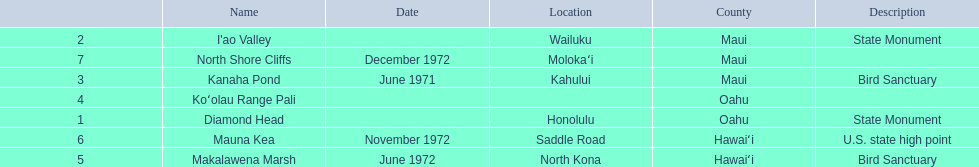What are all of the landmark names? Diamond Head, I'ao Valley, Kanaha Pond, Koʻolau Range Pali, Makalawena Marsh, Mauna Kea, North Shore Cliffs. Where are they located? Honolulu, Wailuku, Kahului, , North Kona, Saddle Road, Molokaʻi. And which landmark has no listed location? Koʻolau Range Pali. 